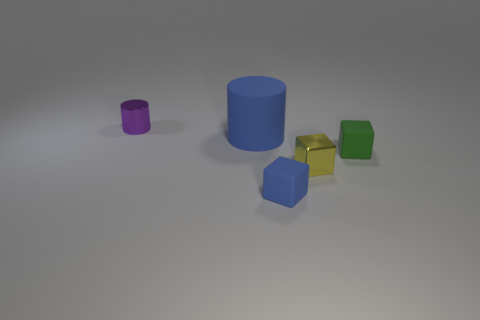Add 1 large blue metal cylinders. How many objects exist? 6 Subtract all blocks. How many objects are left? 2 Subtract 0 cyan spheres. How many objects are left? 5 Subtract all small rubber cubes. Subtract all large brown metal things. How many objects are left? 3 Add 3 tiny green matte objects. How many tiny green matte objects are left? 4 Add 5 blue blocks. How many blue blocks exist? 6 